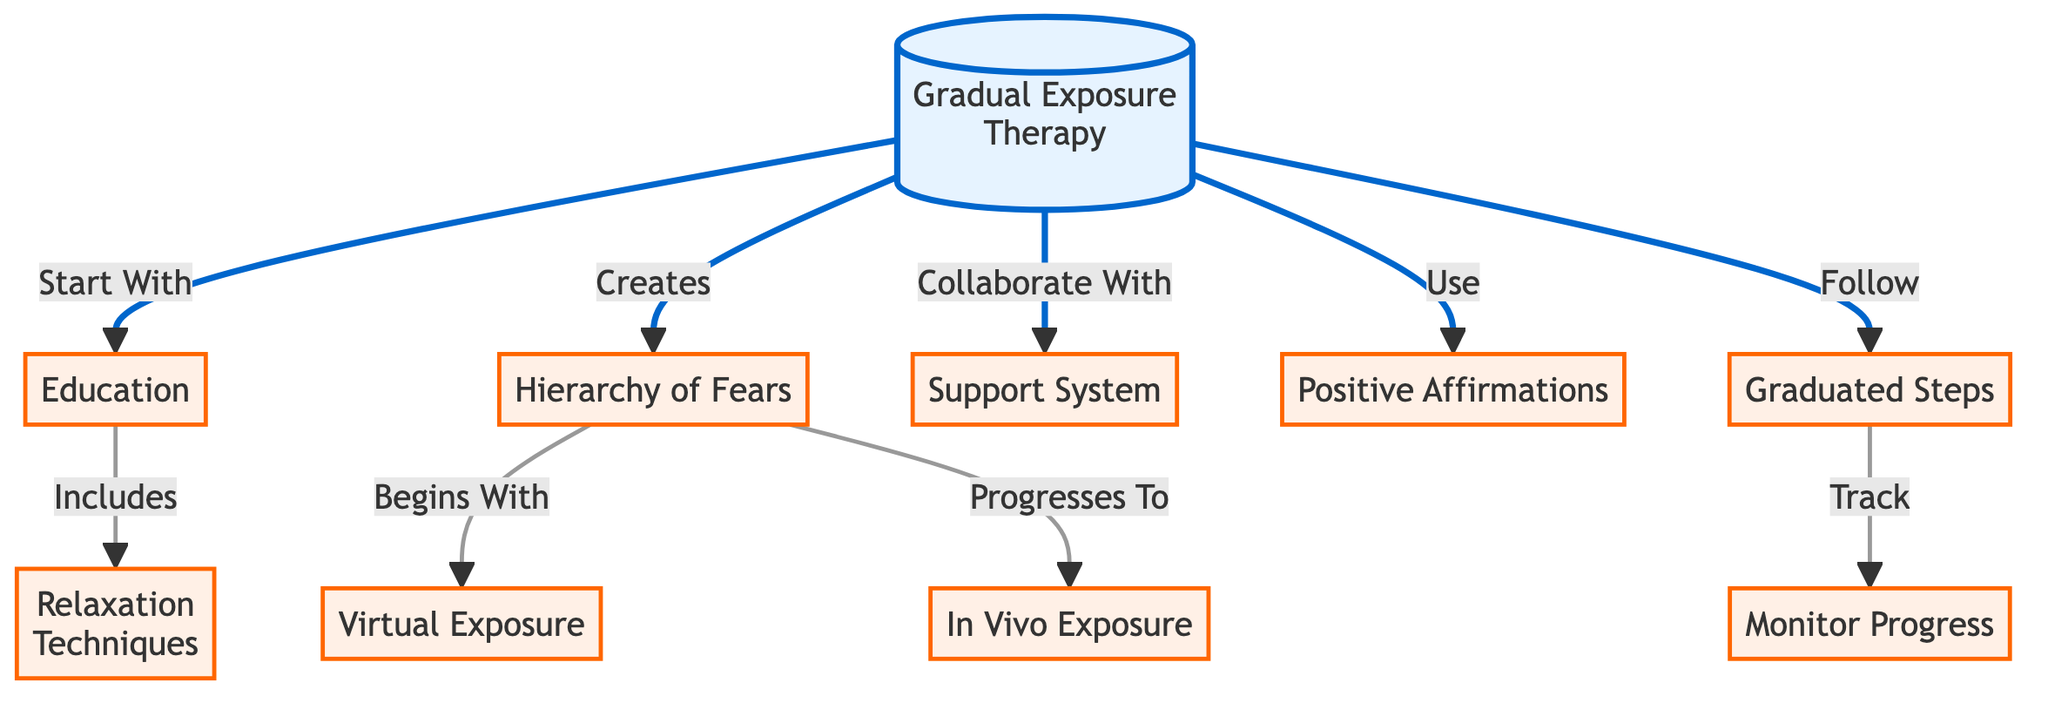What is the first step in the Gradual Exposure Therapy? The diagram indicates that the process starts with "Education," which is the initial step in the Gradual Exposure Therapy.
Answer: Education How many main nodes are visible in the diagram? By counting the nodes that are highlighted as main categories, there are a total of 10 main nodes in the diagram, including "Gradual Exposure Therapy" and the individual techniques or components.
Answer: 10 What does the hierarchy of fears begin with? The diagram specifies that the "Hierarchy of Fears" begins with "Virtual Exposure," which is the first component within that particular hierarchy.
Answer: Virtual Exposure What follows after graduated steps? According to the diagram, "Monitor Progress" follows after the "Graduated Steps," indicating this is the next action taken in the process.
Answer: Monitor Progress Which technique is used alongside support? The diagram shows that "Positive Affirmations" are used in collaboration with the "Support System," indicating their simultaneous importance in therapy.
Answer: Positive Affirmations In what way does the hierarchy progress? From the diagram, it shows that the "Hierarchy of Fears" progresses from "Virtual Exposure" to "In Vivo Exposure," denoting a sequential structure in overcoming fears.
Answer: In Vivo Exposure What connects relaxation techniques to education? The diagram indicates that "Relaxation Techniques" are included as part of the broader category of "Education," highlighting their role in the initial phase.
Answer: Included Which two components work together in the therapy approach? The diagram demonstrates a collaboration between "Support System" and "Graduated Steps," indicating they are linked as essential elements of the therapy approach.
Answer: Support System and Graduated Steps 